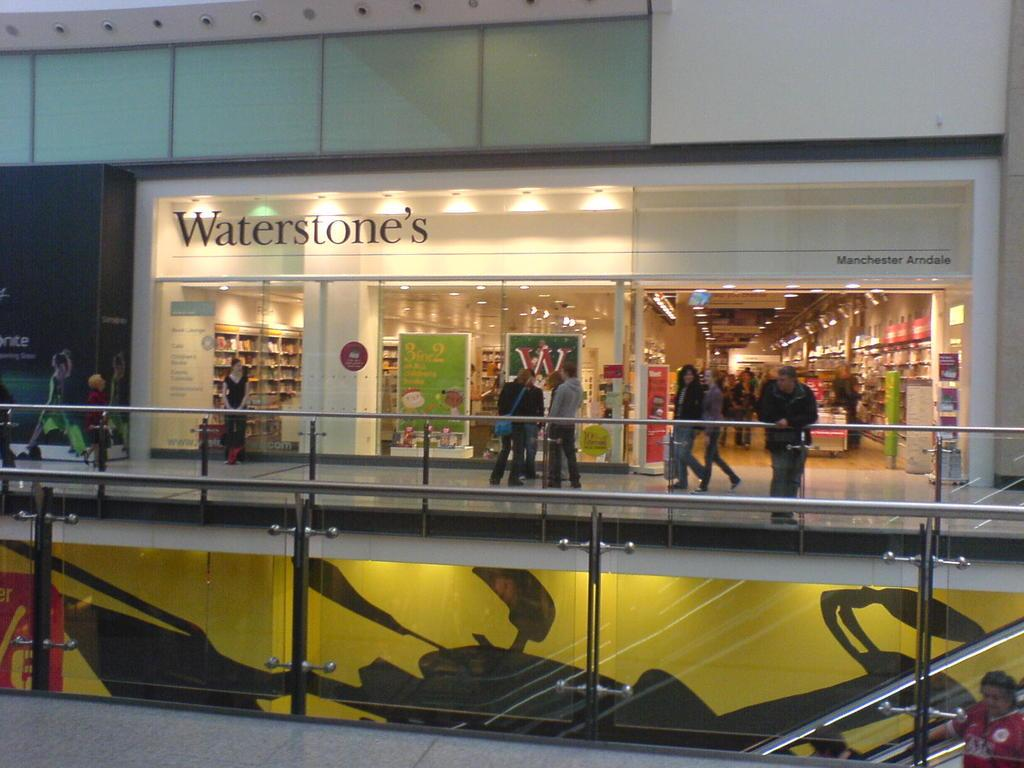What is the main subject of the image? The image depicts a building. Are there any people present in the image? Yes, there are people in the image. What types of establishments can be found in the building? There are stores in the building. What additional features can be seen inside the building? There are boards and railings in the building. What is visible at the top of the building? There are lights at the top of the building. Can you tell me what color the grape is that someone is holding in the image? There is no grape present in the image, so it is not possible to determine its color. 